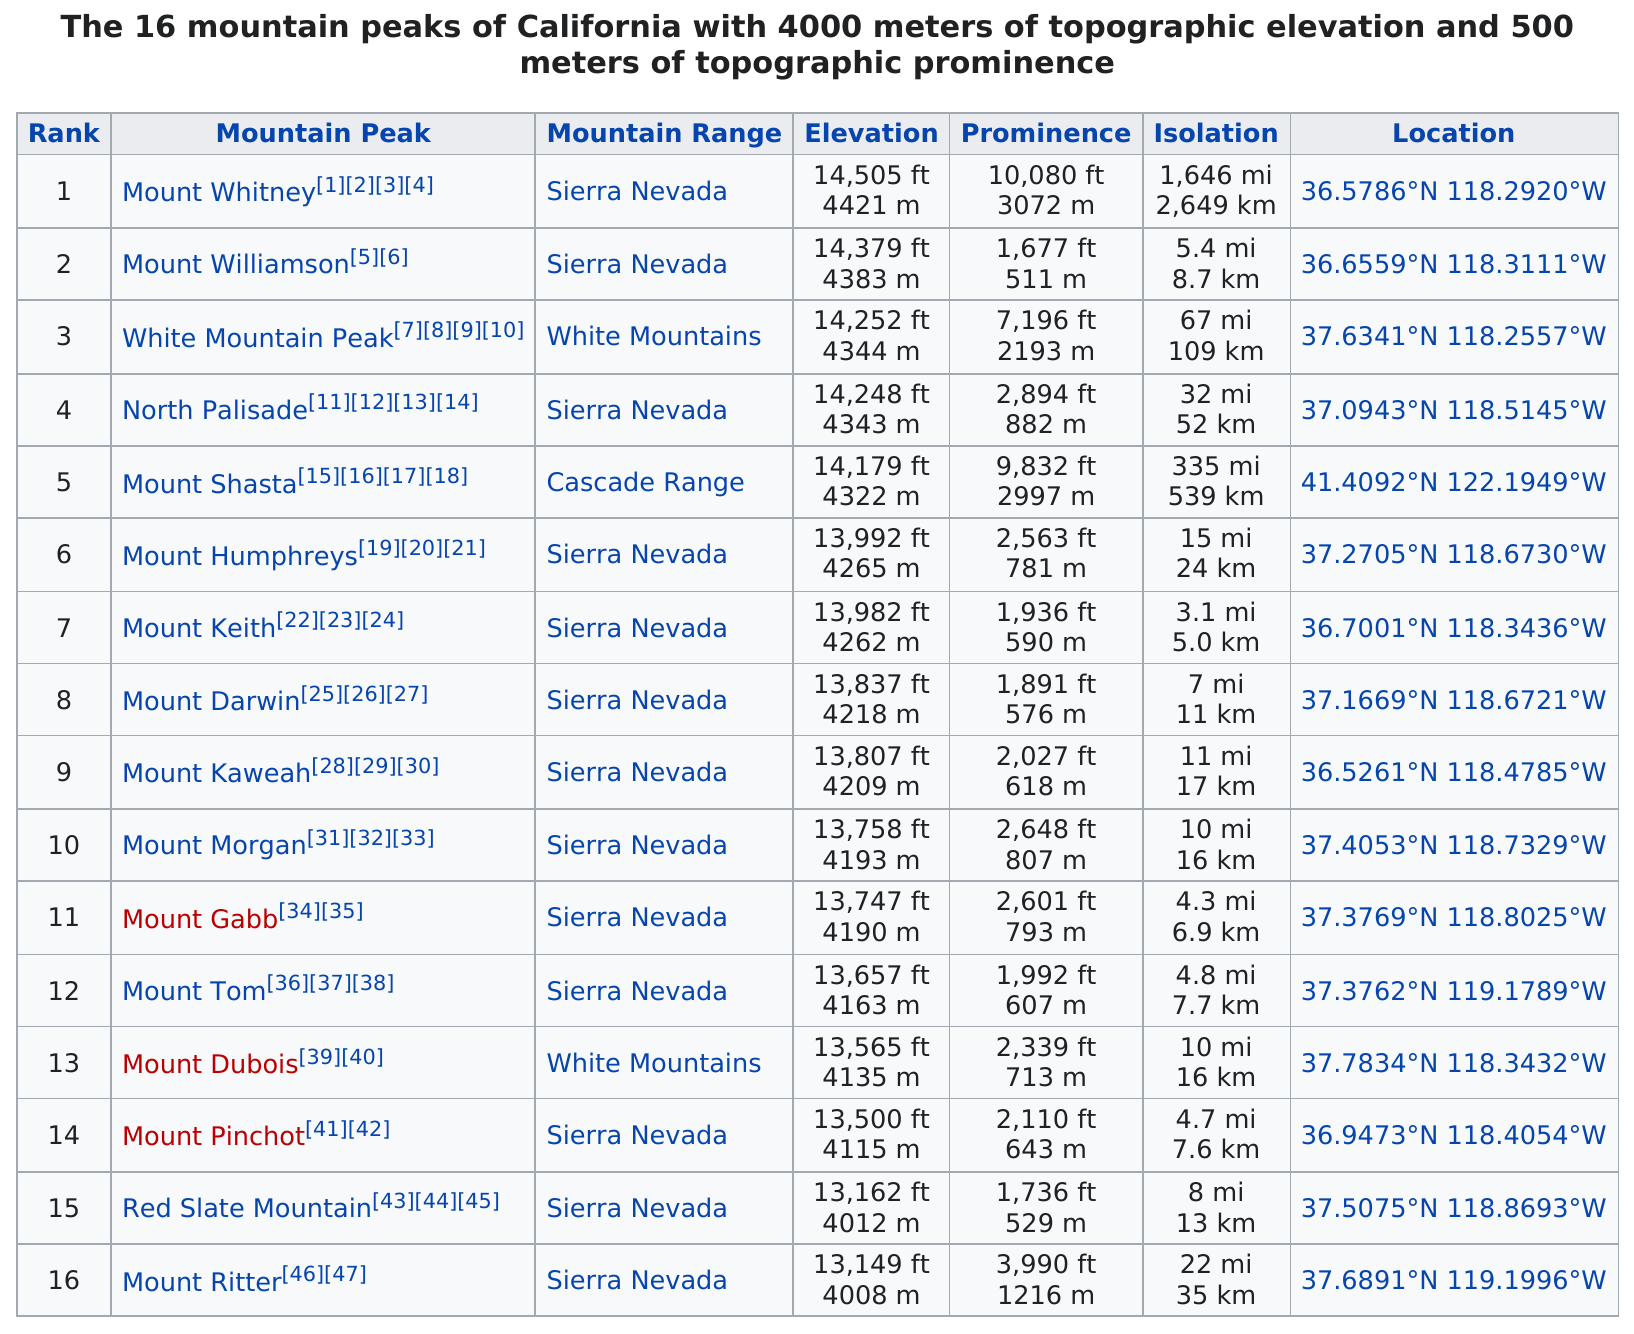Highlight a few significant elements in this photo. Mount Whitney is the mountain peak with the most isolation. Mount Whitney has a total elevation of 14,505 feet. Mount Shasta is the only mountain peak in the Cascades Range that is listed. Mount Keith, which is the peak of a mountain, has the least isolation among all mountain peaks. The difference in height between the tallest peak and the 9th tallest peak in California is 698 feet. 